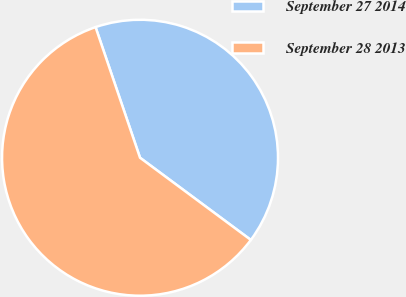Convert chart. <chart><loc_0><loc_0><loc_500><loc_500><pie_chart><fcel>September 27 2014<fcel>September 28 2013<nl><fcel>40.38%<fcel>59.62%<nl></chart> 